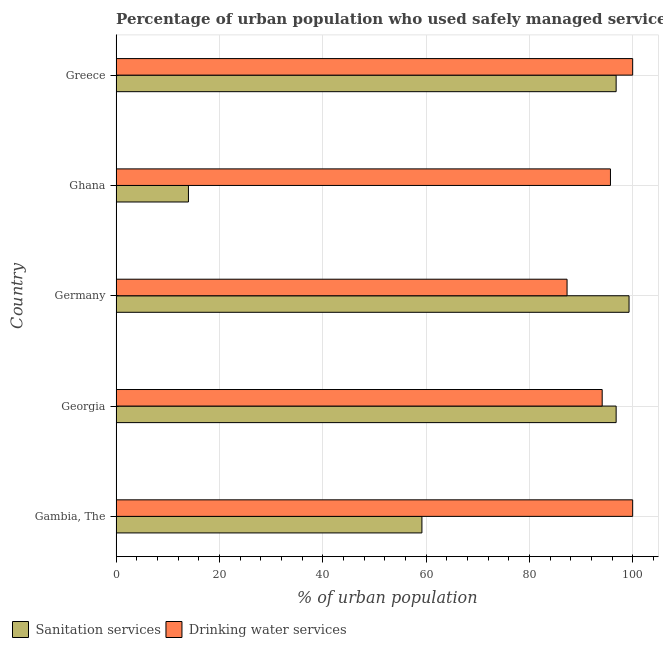How many groups of bars are there?
Your answer should be very brief. 5. Are the number of bars on each tick of the Y-axis equal?
Provide a short and direct response. Yes. How many bars are there on the 2nd tick from the bottom?
Your answer should be compact. 2. What is the label of the 3rd group of bars from the top?
Your answer should be compact. Germany. In how many cases, is the number of bars for a given country not equal to the number of legend labels?
Your answer should be compact. 0. What is the percentage of urban population who used sanitation services in Ghana?
Give a very brief answer. 14. Across all countries, what is the maximum percentage of urban population who used sanitation services?
Ensure brevity in your answer.  99.3. Across all countries, what is the minimum percentage of urban population who used sanitation services?
Offer a terse response. 14. What is the total percentage of urban population who used drinking water services in the graph?
Your answer should be very brief. 477.1. What is the difference between the percentage of urban population who used sanitation services in Ghana and that in Greece?
Your answer should be compact. -82.8. What is the difference between the percentage of urban population who used sanitation services in Gambia, The and the percentage of urban population who used drinking water services in Germany?
Provide a short and direct response. -28.1. What is the average percentage of urban population who used drinking water services per country?
Your answer should be compact. 95.42. What is the ratio of the percentage of urban population who used drinking water services in Germany to that in Ghana?
Give a very brief answer. 0.91. Is the percentage of urban population who used drinking water services in Gambia, The less than that in Greece?
Your answer should be compact. No. Is the difference between the percentage of urban population who used sanitation services in Georgia and Greece greater than the difference between the percentage of urban population who used drinking water services in Georgia and Greece?
Provide a succinct answer. Yes. What is the difference between the highest and the lowest percentage of urban population who used sanitation services?
Ensure brevity in your answer.  85.3. In how many countries, is the percentage of urban population who used sanitation services greater than the average percentage of urban population who used sanitation services taken over all countries?
Keep it short and to the point. 3. What does the 2nd bar from the top in Georgia represents?
Offer a very short reply. Sanitation services. What does the 2nd bar from the bottom in Ghana represents?
Provide a succinct answer. Drinking water services. How many bars are there?
Your answer should be compact. 10. What is the difference between two consecutive major ticks on the X-axis?
Provide a short and direct response. 20. Does the graph contain any zero values?
Provide a short and direct response. No. Does the graph contain grids?
Provide a succinct answer. Yes. How are the legend labels stacked?
Make the answer very short. Horizontal. What is the title of the graph?
Offer a terse response. Percentage of urban population who used safely managed services in 1994. What is the label or title of the X-axis?
Keep it short and to the point. % of urban population. What is the % of urban population of Sanitation services in Gambia, The?
Your response must be concise. 59.2. What is the % of urban population in Sanitation services in Georgia?
Your answer should be compact. 96.8. What is the % of urban population in Drinking water services in Georgia?
Provide a succinct answer. 94.1. What is the % of urban population of Sanitation services in Germany?
Keep it short and to the point. 99.3. What is the % of urban population in Drinking water services in Germany?
Make the answer very short. 87.3. What is the % of urban population of Drinking water services in Ghana?
Your answer should be compact. 95.7. What is the % of urban population in Sanitation services in Greece?
Your answer should be compact. 96.8. What is the % of urban population of Drinking water services in Greece?
Provide a succinct answer. 100. Across all countries, what is the maximum % of urban population of Sanitation services?
Ensure brevity in your answer.  99.3. Across all countries, what is the minimum % of urban population of Drinking water services?
Your response must be concise. 87.3. What is the total % of urban population in Sanitation services in the graph?
Provide a short and direct response. 366.1. What is the total % of urban population of Drinking water services in the graph?
Offer a very short reply. 477.1. What is the difference between the % of urban population in Sanitation services in Gambia, The and that in Georgia?
Offer a very short reply. -37.6. What is the difference between the % of urban population of Drinking water services in Gambia, The and that in Georgia?
Provide a succinct answer. 5.9. What is the difference between the % of urban population in Sanitation services in Gambia, The and that in Germany?
Your answer should be very brief. -40.1. What is the difference between the % of urban population in Drinking water services in Gambia, The and that in Germany?
Provide a succinct answer. 12.7. What is the difference between the % of urban population in Sanitation services in Gambia, The and that in Ghana?
Your response must be concise. 45.2. What is the difference between the % of urban population of Sanitation services in Gambia, The and that in Greece?
Your response must be concise. -37.6. What is the difference between the % of urban population in Drinking water services in Gambia, The and that in Greece?
Provide a succinct answer. 0. What is the difference between the % of urban population in Drinking water services in Georgia and that in Germany?
Make the answer very short. 6.8. What is the difference between the % of urban population of Sanitation services in Georgia and that in Ghana?
Keep it short and to the point. 82.8. What is the difference between the % of urban population in Drinking water services in Georgia and that in Ghana?
Your response must be concise. -1.6. What is the difference between the % of urban population of Drinking water services in Georgia and that in Greece?
Your answer should be very brief. -5.9. What is the difference between the % of urban population of Sanitation services in Germany and that in Ghana?
Provide a short and direct response. 85.3. What is the difference between the % of urban population of Sanitation services in Ghana and that in Greece?
Offer a very short reply. -82.8. What is the difference between the % of urban population in Sanitation services in Gambia, The and the % of urban population in Drinking water services in Georgia?
Offer a very short reply. -34.9. What is the difference between the % of urban population of Sanitation services in Gambia, The and the % of urban population of Drinking water services in Germany?
Your answer should be very brief. -28.1. What is the difference between the % of urban population of Sanitation services in Gambia, The and the % of urban population of Drinking water services in Ghana?
Keep it short and to the point. -36.5. What is the difference between the % of urban population in Sanitation services in Gambia, The and the % of urban population in Drinking water services in Greece?
Make the answer very short. -40.8. What is the difference between the % of urban population of Sanitation services in Georgia and the % of urban population of Drinking water services in Germany?
Your answer should be compact. 9.5. What is the difference between the % of urban population of Sanitation services in Georgia and the % of urban population of Drinking water services in Greece?
Ensure brevity in your answer.  -3.2. What is the difference between the % of urban population in Sanitation services in Germany and the % of urban population in Drinking water services in Greece?
Offer a very short reply. -0.7. What is the difference between the % of urban population of Sanitation services in Ghana and the % of urban population of Drinking water services in Greece?
Give a very brief answer. -86. What is the average % of urban population of Sanitation services per country?
Make the answer very short. 73.22. What is the average % of urban population in Drinking water services per country?
Your answer should be compact. 95.42. What is the difference between the % of urban population in Sanitation services and % of urban population in Drinking water services in Gambia, The?
Offer a very short reply. -40.8. What is the difference between the % of urban population of Sanitation services and % of urban population of Drinking water services in Georgia?
Your response must be concise. 2.7. What is the difference between the % of urban population in Sanitation services and % of urban population in Drinking water services in Ghana?
Provide a short and direct response. -81.7. What is the ratio of the % of urban population in Sanitation services in Gambia, The to that in Georgia?
Give a very brief answer. 0.61. What is the ratio of the % of urban population of Drinking water services in Gambia, The to that in Georgia?
Make the answer very short. 1.06. What is the ratio of the % of urban population in Sanitation services in Gambia, The to that in Germany?
Your response must be concise. 0.6. What is the ratio of the % of urban population in Drinking water services in Gambia, The to that in Germany?
Your answer should be very brief. 1.15. What is the ratio of the % of urban population in Sanitation services in Gambia, The to that in Ghana?
Provide a succinct answer. 4.23. What is the ratio of the % of urban population of Drinking water services in Gambia, The to that in Ghana?
Provide a succinct answer. 1.04. What is the ratio of the % of urban population in Sanitation services in Gambia, The to that in Greece?
Keep it short and to the point. 0.61. What is the ratio of the % of urban population in Drinking water services in Gambia, The to that in Greece?
Keep it short and to the point. 1. What is the ratio of the % of urban population of Sanitation services in Georgia to that in Germany?
Keep it short and to the point. 0.97. What is the ratio of the % of urban population in Drinking water services in Georgia to that in Germany?
Provide a succinct answer. 1.08. What is the ratio of the % of urban population in Sanitation services in Georgia to that in Ghana?
Your answer should be compact. 6.91. What is the ratio of the % of urban population of Drinking water services in Georgia to that in Ghana?
Offer a very short reply. 0.98. What is the ratio of the % of urban population in Sanitation services in Georgia to that in Greece?
Keep it short and to the point. 1. What is the ratio of the % of urban population in Drinking water services in Georgia to that in Greece?
Ensure brevity in your answer.  0.94. What is the ratio of the % of urban population of Sanitation services in Germany to that in Ghana?
Provide a short and direct response. 7.09. What is the ratio of the % of urban population of Drinking water services in Germany to that in Ghana?
Ensure brevity in your answer.  0.91. What is the ratio of the % of urban population in Sanitation services in Germany to that in Greece?
Give a very brief answer. 1.03. What is the ratio of the % of urban population in Drinking water services in Germany to that in Greece?
Offer a terse response. 0.87. What is the ratio of the % of urban population in Sanitation services in Ghana to that in Greece?
Your answer should be compact. 0.14. What is the ratio of the % of urban population of Drinking water services in Ghana to that in Greece?
Ensure brevity in your answer.  0.96. What is the difference between the highest and the second highest % of urban population in Sanitation services?
Make the answer very short. 2.5. What is the difference between the highest and the second highest % of urban population in Drinking water services?
Offer a terse response. 0. What is the difference between the highest and the lowest % of urban population in Sanitation services?
Offer a terse response. 85.3. 